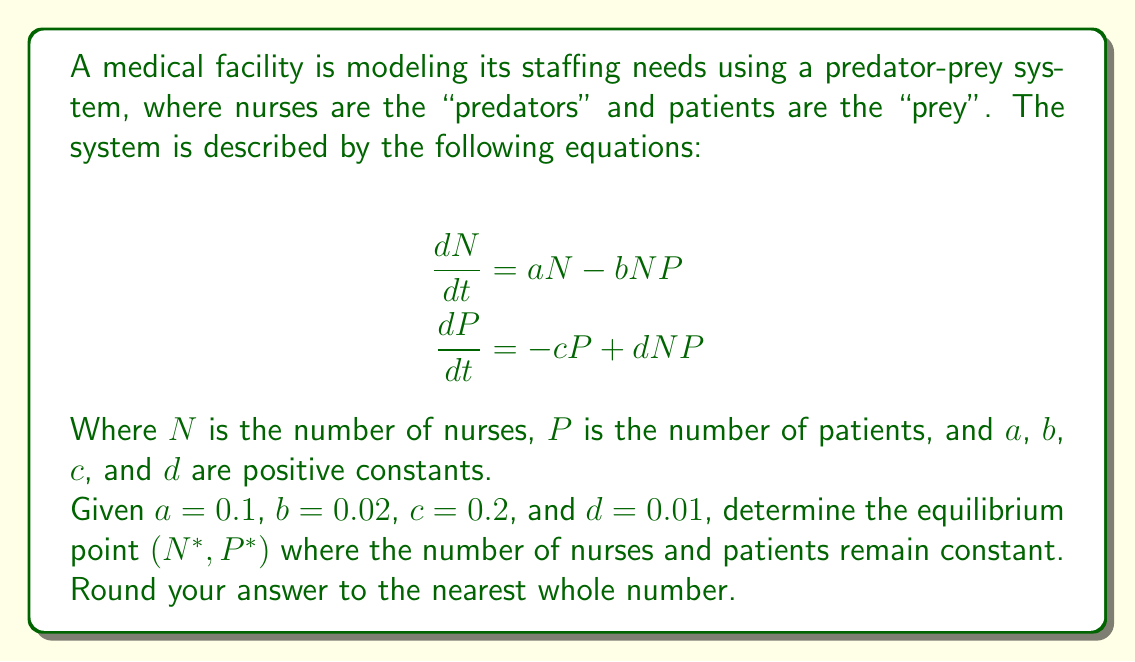Could you help me with this problem? To find the equilibrium point, we need to set both equations equal to zero and solve for $N$ and $P$:

1) Set $\frac{dN}{dt} = 0$ and $\frac{dP}{dt} = 0$:

   $$0 = aN - bNP$$
   $$0 = -cP + dNP$$

2) From the first equation:
   $$aN = bNP$$
   $$a = bP$$ (assuming $N \neq 0$)
   $$P^* = \frac{a}{b} = \frac{0.1}{0.02} = 5$$

3) From the second equation:
   $$cP = dNP$$
   $$c = dN$$ (assuming $P \neq 0$)
   $$N^* = \frac{c}{d} = \frac{0.2}{0.01} = 20$$

4) Therefore, the equilibrium point is $(N^*, P^*) = (20, 5)$.

5) Rounding to the nearest whole number is not necessary in this case as both values are already whole numbers.

This equilibrium point represents the optimal staffing level (20 nurses) for the given patient load (5 patients) where the system remains stable over time.
Answer: $(20, 5)$ 